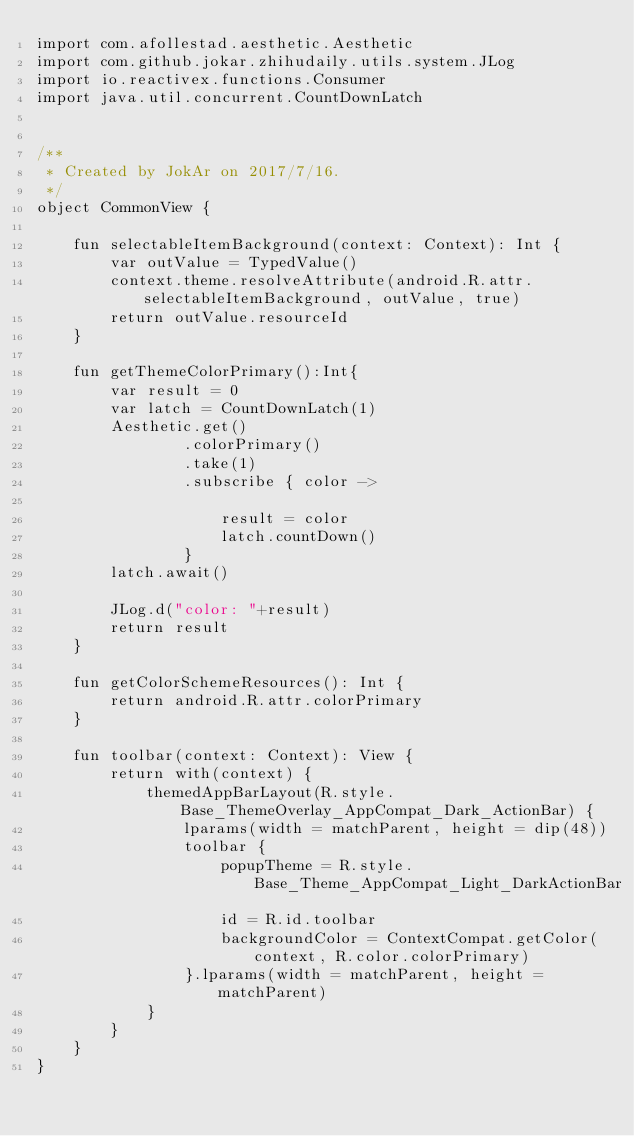<code> <loc_0><loc_0><loc_500><loc_500><_Kotlin_>import com.afollestad.aesthetic.Aesthetic
import com.github.jokar.zhihudaily.utils.system.JLog
import io.reactivex.functions.Consumer
import java.util.concurrent.CountDownLatch


/**
 * Created by JokAr on 2017/7/16.
 */
object CommonView {

    fun selectableItemBackground(context: Context): Int {
        var outValue = TypedValue()
        context.theme.resolveAttribute(android.R.attr.selectableItemBackground, outValue, true)
        return outValue.resourceId
    }

    fun getThemeColorPrimary():Int{
        var result = 0
        var latch = CountDownLatch(1)
        Aesthetic.get()
                .colorPrimary()
                .take(1)
                .subscribe { color ->

                    result = color
                    latch.countDown()
                }
        latch.await()

        JLog.d("color: "+result)
        return result
    }

    fun getColorSchemeResources(): Int {
        return android.R.attr.colorPrimary
    }

    fun toolbar(context: Context): View {
        return with(context) {
            themedAppBarLayout(R.style.Base_ThemeOverlay_AppCompat_Dark_ActionBar) {
                lparams(width = matchParent, height = dip(48))
                toolbar {
                    popupTheme = R.style.Base_Theme_AppCompat_Light_DarkActionBar
                    id = R.id.toolbar
                    backgroundColor = ContextCompat.getColor(context, R.color.colorPrimary)
                }.lparams(width = matchParent, height = matchParent)
            }
        }
    }
}</code> 